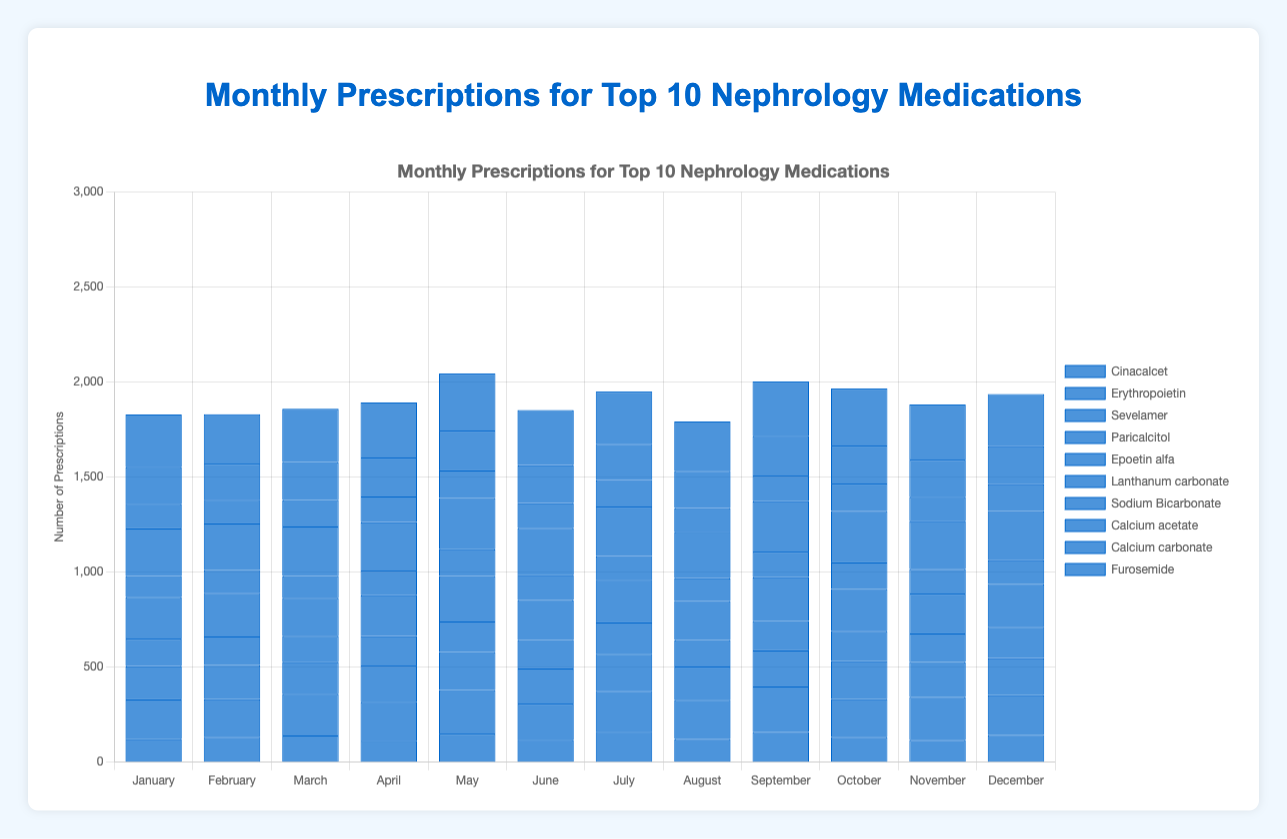What is the average number of prescriptions for Cinacalcet over the year? To calculate the average, sum the prescriptions for all months and divide by the number of months: (120 + 133 + 140 + 113 + 150 + 118 + 160 + 121 + 158 + 133 + 117 + 142) / 12 = 1605 / 12 = 133.75
Answer: 133.75 In which month did Erythropoietin have the highest number of prescriptions? Compare the number of prescriptions for Erythropoietin across all months and identify the maximum value: The highest number is 240 in September
Answer: September Which medication had the most prescriptions in May? Look at the prescriptions for all medications in May and find the maximum value: Sodium Bicarbonate had 270 prescriptions, which is the highest among all
Answer: Sodium Bicarbonate Which medication had the lowest total prescriptions over the year? Sum the prescriptions for each medication across all months and find the minimum total: Lanthanum carbonate has the lowest total. Totals: Cinacalcet (1605), Erythropoietin (2548), Sevelamer (2235), Paricalcitol (1845), Epoetin alfa (2645), Lanthanum carbonate (1450), Sodium Bicarbonate (3120), Calcium acetate (1650), Calcium carbonate (2390), Furosemide (3390)
Answer: Lanthanum carbonate How did the prescriptions for Furosemide change from June to July? Subtract the number of prescriptions in June from those in July: 290 (June) - 275 (July) = -15, indicating a decrease of 15 prescriptions
Answer: Decreased by 15 Which two medications had the closest number of prescriptions in November? Compare the number of prescriptions for all medications in November and identify the two with the smallest difference: Erythropoietin and Epoetin alfa both had 210, making them the closest
Answer: Erythropoietin and Epoetin alfa What is the total number of prescriptions for Sodium Bicarbonate and Calcium carbonate in March? Sum the prescriptions for both medications in March: 260 (Sodium Bicarbonate) + 200 (Calcium carbonate) = 460
Answer: 460 Which month saw the highest overall prescriptions across all medications? Sum the prescriptions for all medications in each month and identify the month with the highest total: January total: 1825, February: 1831, March: 1880, April: 1888, May: 2095, June: 1863, July: 1920, August: 1818, September: 2088, October: 2036, November: 1927, December: 1937. The highest is May with 2095
Answer: May How did the total prescriptions for Epoetin alfa in the first half of the year compare to the second half? Sum the prescriptions for the first half (January to June) and compare with the second half (July to December): First half: (220 + 230 + 200 + 215 + 240 + 210) = 1315, Second half: (225 + 205 + 230 + 220 + 210 + 225) = 1315, so they are equal
Answer: Equal 